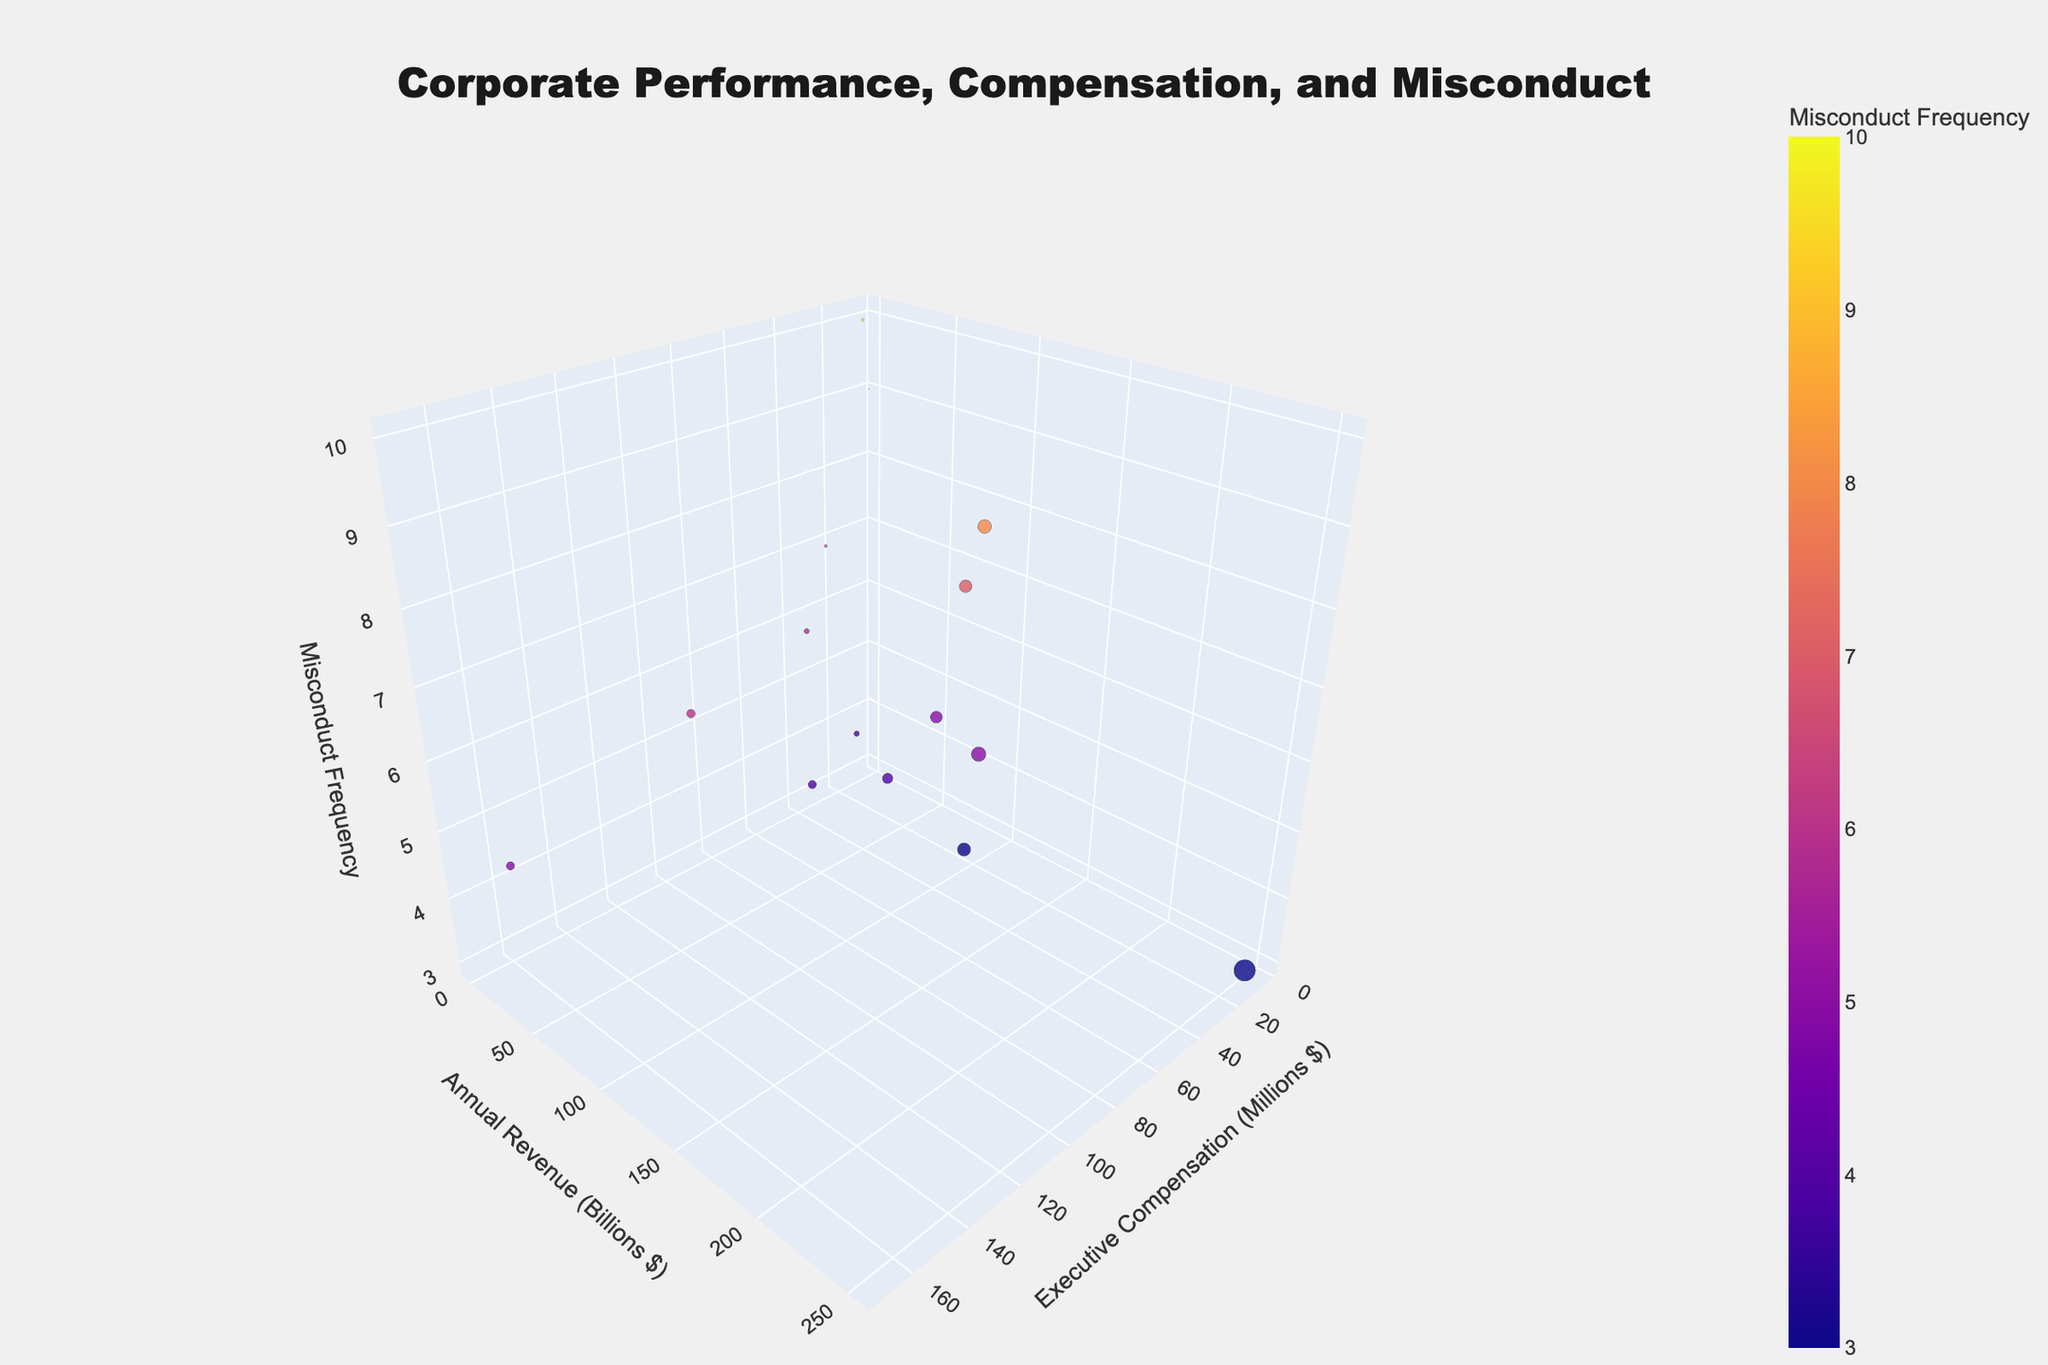What's the title of the plot? The title is located at the top center of the plot. It is clearly visible and provides a summary of what the plot represents.
Answer: Corporate Performance, Compensation, and Misconduct How many companies are displayed in the plot? To find the number of data points, count the markers representing different companies in the 3D scatter plot.
Answer: 15 Which company shows the highest executive compensation? Look at the x-axis labeled "Executive Compensation (Millions $)" and find the company placed furthest to the right.
Answer: Tyco Which company has the highest frequency of misconduct? Refer to the z-axis labeled "Misconduct Frequency" and find the highest positioned marker along this axis.
Answer: Wirecard Which company has the largest annual revenue? Check the size of the markers, as they represent annual revenue, and identify the largest one.
Answer: Volkswagen What are the executive compensation and annual revenue for Volkswagen? Locate the marker for Volkswagen and read the values off the x-axis (executive compensation) and y-axis (annual revenue).
Answer: 9.7 million, 252.6 billion Do higher executive compensations correlate with higher frequencies of misconduct? Observe the distribution of the markers along the x-axis and z-axis to identify if there is a general trend.
Answer: No clear correlation Which company has the smallest annual revenue and what is its misconduct frequency? Find the smallest marker in terms of size and then look at its position along the z-axis.
Answer: Theranos, 9 What is the average frequency of misconduct among the companies? Sum all the misconduct frequency values from the z-axis data and divide by the number of companies.
Answer: (8 + 6 + 5 + 4 + 7 + 3 + 5 + 9 + 6 + 4 + 5 + 3 + 10 + 4 + 7) / 15 = 5.53 How does Lehman Brothers compare with Goldman Sachs in terms of executive compensation and annual revenue? Compare the positions of Lehman Brothers and Goldman Sachs along the x-axis (executive compensation) and y-axis (annual revenue).
Answer: Lehman Brothers: 34.4 million, 59.3 billion; Goldman Sachs: 54.9 million, 36.5 billion 